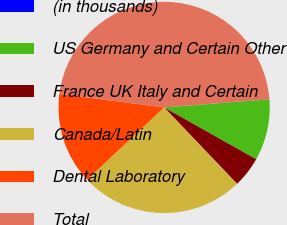<chart> <loc_0><loc_0><loc_500><loc_500><pie_chart><fcel>(in thousands)<fcel>US Germany and Certain Other<fcel>France UK Italy and Certain<fcel>Canada/Latin<fcel>Dental Laboratory<fcel>Total<nl><fcel>0.04%<fcel>9.37%<fcel>4.71%<fcel>25.13%<fcel>14.04%<fcel>46.7%<nl></chart> 